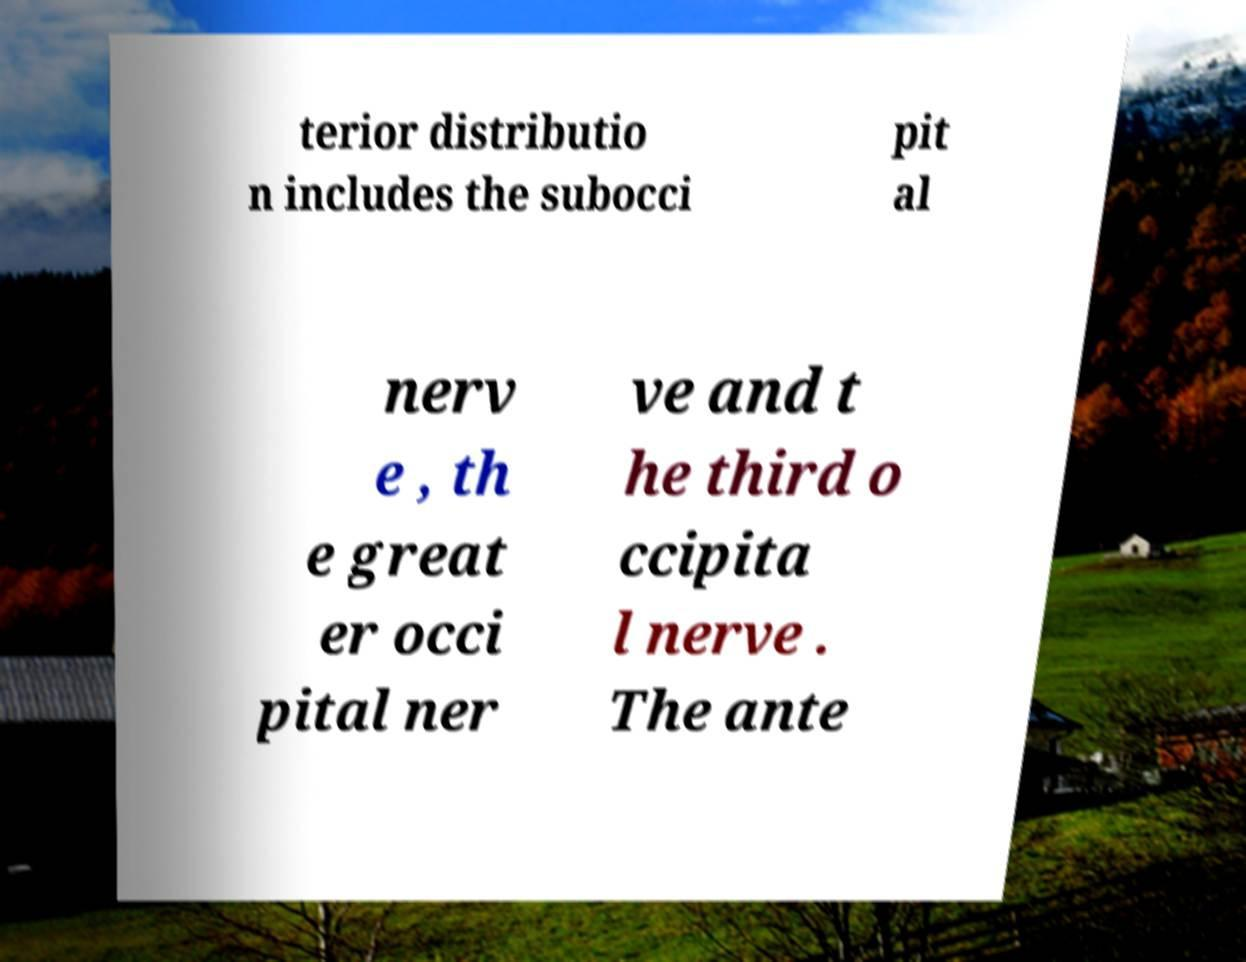Can you accurately transcribe the text from the provided image for me? terior distributio n includes the subocci pit al nerv e , th e great er occi pital ner ve and t he third o ccipita l nerve . The ante 